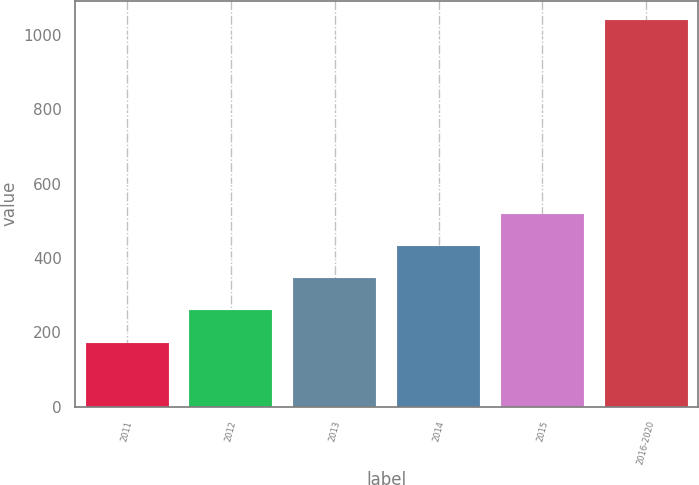Convert chart to OTSL. <chart><loc_0><loc_0><loc_500><loc_500><bar_chart><fcel>2011<fcel>2012<fcel>2013<fcel>2014<fcel>2015<fcel>2016-2020<nl><fcel>172<fcel>258.7<fcel>345.4<fcel>432.1<fcel>518.8<fcel>1039<nl></chart> 